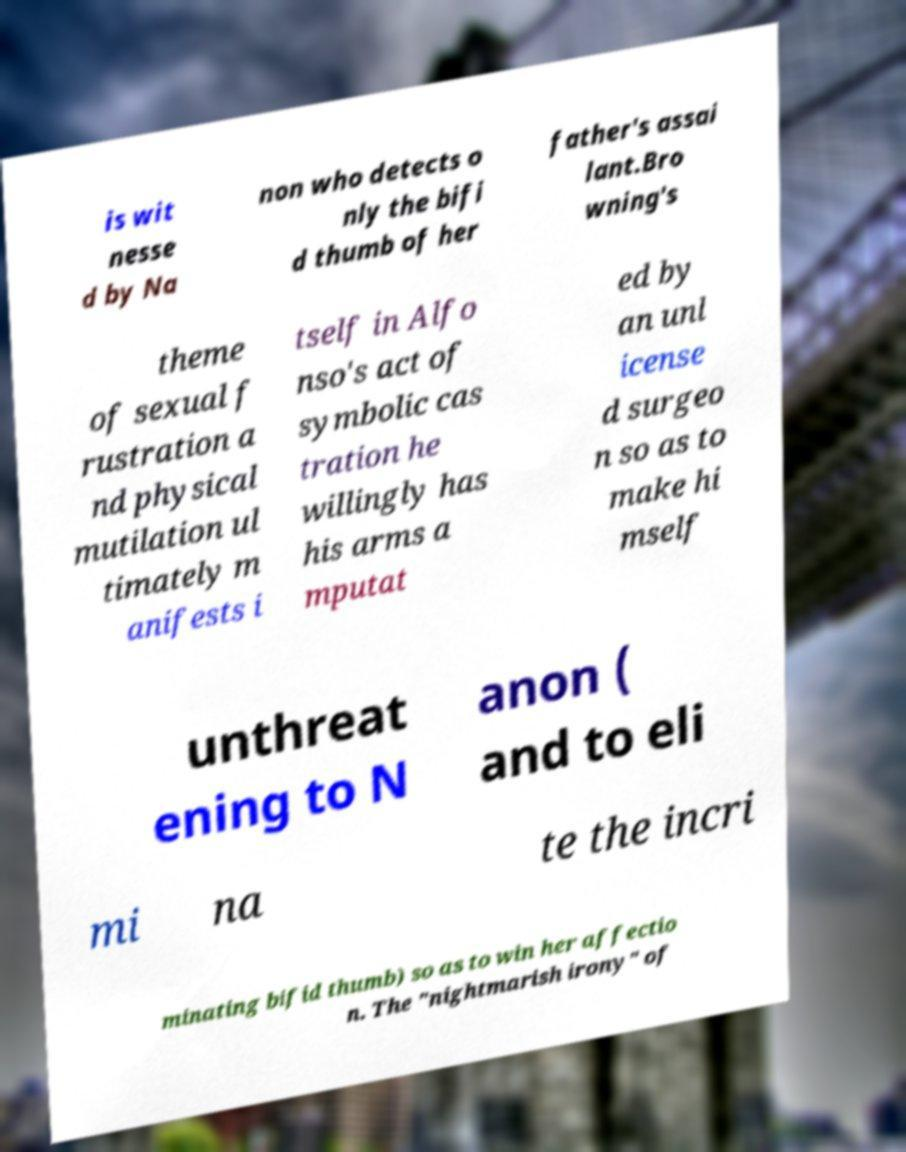Please read and relay the text visible in this image. What does it say? is wit nesse d by Na non who detects o nly the bifi d thumb of her father's assai lant.Bro wning's theme of sexual f rustration a nd physical mutilation ul timately m anifests i tself in Alfo nso's act of symbolic cas tration he willingly has his arms a mputat ed by an unl icense d surgeo n so as to make hi mself unthreat ening to N anon ( and to eli mi na te the incri minating bifid thumb) so as to win her affectio n. The "nightmarish irony" of 